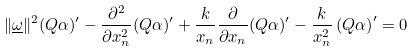Convert formula to latex. <formula><loc_0><loc_0><loc_500><loc_500>\| \underline { \omega } \| ^ { 2 } ( Q \alpha ) ^ { \prime } - \frac { \partial ^ { 2 } } { \partial x _ { n } ^ { 2 } } ( Q \alpha ) ^ { \prime } + \frac { k } { x _ { n } } \frac { \partial } { \partial x _ { n } } ( Q \alpha ) ^ { \prime } - \frac { k } { x _ { n } ^ { 2 } } \left ( Q \alpha \right ) ^ { \prime } = 0</formula> 